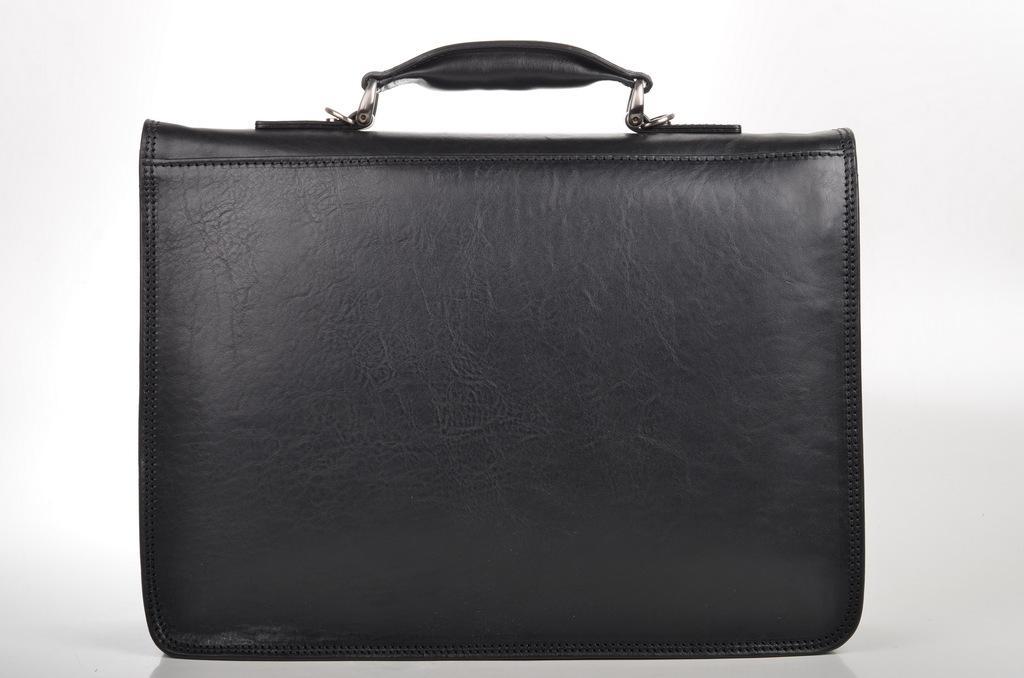Can you describe this image briefly? In this image in the middle there is a black color bag with handle. 